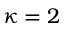<formula> <loc_0><loc_0><loc_500><loc_500>\kappa = 2</formula> 